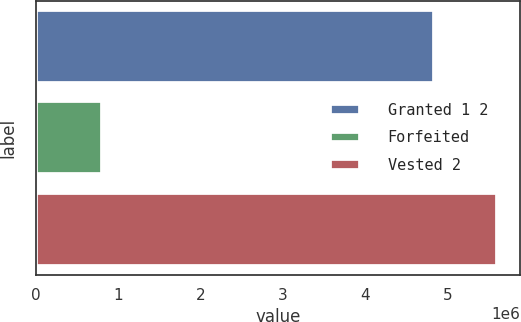Convert chart. <chart><loc_0><loc_0><loc_500><loc_500><bar_chart><fcel>Granted 1 2<fcel>Forfeited<fcel>Vested 2<nl><fcel>4.83254e+06<fcel>800429<fcel>5.60211e+06<nl></chart> 